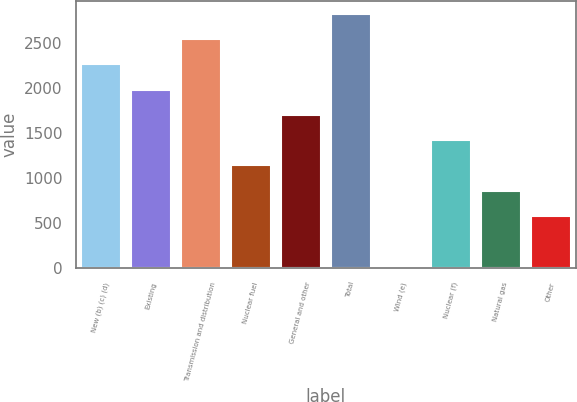Convert chart to OTSL. <chart><loc_0><loc_0><loc_500><loc_500><bar_chart><fcel>New (b) (c) (d)<fcel>Existing<fcel>Transmission and distribution<fcel>Nuclear fuel<fcel>General and other<fcel>Total<fcel>Wind (e)<fcel>Nuclear (f)<fcel>Natural gas<fcel>Other<nl><fcel>2264<fcel>1983.5<fcel>2544.5<fcel>1142<fcel>1703<fcel>2825<fcel>20<fcel>1422.5<fcel>861.5<fcel>581<nl></chart> 